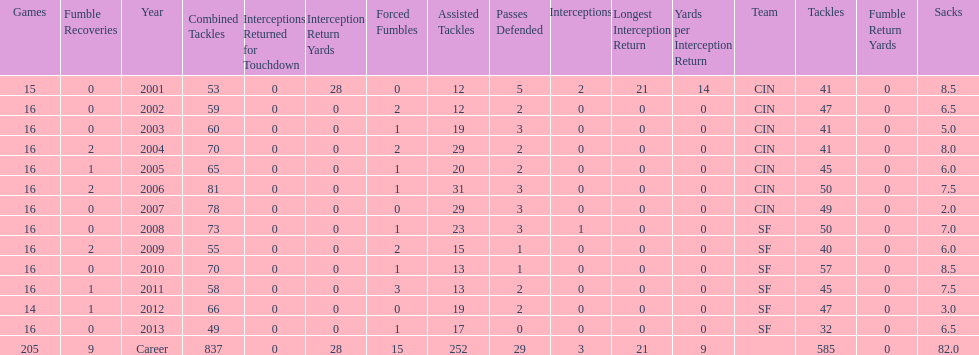How many fumble recoveries did this player have in 2004? 2. 